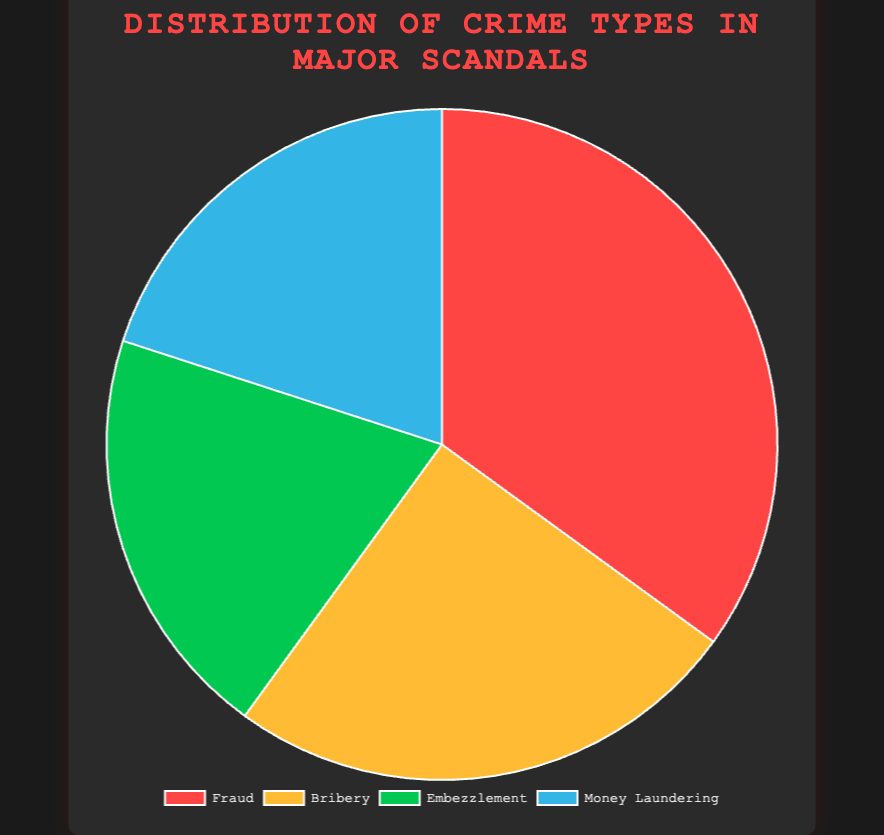What's the most common type of crime in major scandals? By inspecting the largest segment of the pie chart, the crime type with the highest percentage can be identified. The largest segment is associated with "Fraud" at 35%.
Answer: Fraud Which crime types have an equal distribution in major scandals? By looking at the pie chart, we can see which segments have the same size. Both "Embezzlement" and "Money Laundering" segments are equal, each having 20%.
Answer: Embezzlement and Money Laundering What is the combined percentage of Bribery and Embezzlement in major scandals? To find the combined percentage, add the percentages of Bribery (25%) and Embezzlement (20%). Thus, 25% + 20% = 45%.
Answer: 45% Is the percentage of Fraud greater than Embezzlement and Money Laundering combined? The percentage of Fraud is 35%. The combined percentage of Embezzlement (20%) and Money Laundering (20%) is 40%, which is greater than 35%.
Answer: No Which crime type has a higher percentage, Bribery or Money Laundering? By comparing the percentages directly, Bribery is 25% and Money Laundering is 20%. Therefore, Bribery is higher.
Answer: Bribery Which colored segment represents the crime type with the second-highest percentage in major scandals? The second-largest segment is labeled "Bribery" with 25%, and in the pie chart's legend, it is represented by the color yellow.
Answer: Yellow How much higher is the percentage of Fraud compared to Money Laundering? Subtract the percentage of Money Laundering (20%) from Fraud (35%). Thus, 35% - 20% = 15%.
Answer: 15% Which crime type has the smallest segment in the chart, and what color represents it? The two smallest segments are equal, but let's check for one that's mentioned last and confirmed by color code. Embezzlement and Money Laundering both have 20%, with Money Laundering being represented by blue.
Answer: Money Laundering, blue What is the average percentage of the four crime types? To find the average, sum all the percentages (35% + 25% + 20% + 20%) and divide by the number of crime types (4). Thus, (35 + 25 + 20 + 20) / 4 = 25%.
Answer: 25% 